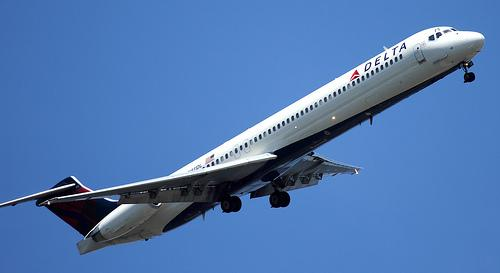Choose a visual element on the plane and provide a brief description. The delta name and emblem is visible on the side of the plane, with a red triangle and the blue word "delta." What is the primary object in the image, and what is its main activity? The primary object is a large white delta airplane flying in the clear blue sky with its nose pointed upward. In the context of the image, discuss the weather and surrounding environment. The image shows clear blue daytime skies, indicating a sunny and bright environment for the airplane to fly in. 